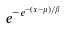Convert formula to latex. <formula><loc_0><loc_0><loc_500><loc_500>e ^ { - e ^ { - ( x - \mu ) / \beta } }</formula> 